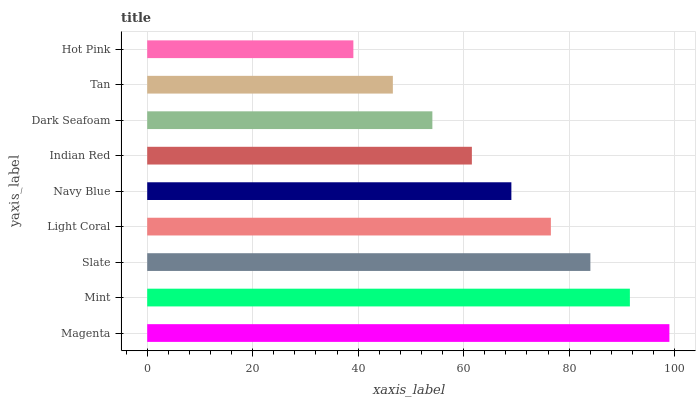Is Hot Pink the minimum?
Answer yes or no. Yes. Is Magenta the maximum?
Answer yes or no. Yes. Is Mint the minimum?
Answer yes or no. No. Is Mint the maximum?
Answer yes or no. No. Is Magenta greater than Mint?
Answer yes or no. Yes. Is Mint less than Magenta?
Answer yes or no. Yes. Is Mint greater than Magenta?
Answer yes or no. No. Is Magenta less than Mint?
Answer yes or no. No. Is Navy Blue the high median?
Answer yes or no. Yes. Is Navy Blue the low median?
Answer yes or no. Yes. Is Slate the high median?
Answer yes or no. No. Is Slate the low median?
Answer yes or no. No. 